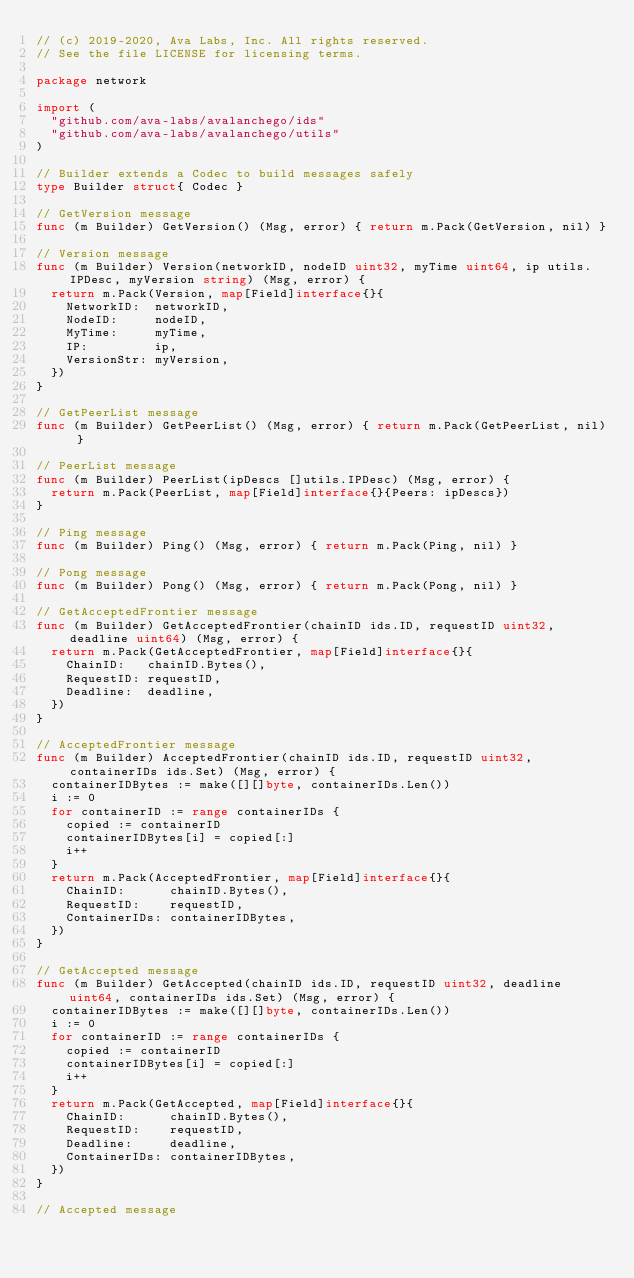Convert code to text. <code><loc_0><loc_0><loc_500><loc_500><_Go_>// (c) 2019-2020, Ava Labs, Inc. All rights reserved.
// See the file LICENSE for licensing terms.

package network

import (
	"github.com/ava-labs/avalanchego/ids"
	"github.com/ava-labs/avalanchego/utils"
)

// Builder extends a Codec to build messages safely
type Builder struct{ Codec }

// GetVersion message
func (m Builder) GetVersion() (Msg, error) { return m.Pack(GetVersion, nil) }

// Version message
func (m Builder) Version(networkID, nodeID uint32, myTime uint64, ip utils.IPDesc, myVersion string) (Msg, error) {
	return m.Pack(Version, map[Field]interface{}{
		NetworkID:  networkID,
		NodeID:     nodeID,
		MyTime:     myTime,
		IP:         ip,
		VersionStr: myVersion,
	})
}

// GetPeerList message
func (m Builder) GetPeerList() (Msg, error) { return m.Pack(GetPeerList, nil) }

// PeerList message
func (m Builder) PeerList(ipDescs []utils.IPDesc) (Msg, error) {
	return m.Pack(PeerList, map[Field]interface{}{Peers: ipDescs})
}

// Ping message
func (m Builder) Ping() (Msg, error) { return m.Pack(Ping, nil) }

// Pong message
func (m Builder) Pong() (Msg, error) { return m.Pack(Pong, nil) }

// GetAcceptedFrontier message
func (m Builder) GetAcceptedFrontier(chainID ids.ID, requestID uint32, deadline uint64) (Msg, error) {
	return m.Pack(GetAcceptedFrontier, map[Field]interface{}{
		ChainID:   chainID.Bytes(),
		RequestID: requestID,
		Deadline:  deadline,
	})
}

// AcceptedFrontier message
func (m Builder) AcceptedFrontier(chainID ids.ID, requestID uint32, containerIDs ids.Set) (Msg, error) {
	containerIDBytes := make([][]byte, containerIDs.Len())
	i := 0
	for containerID := range containerIDs {
		copied := containerID
		containerIDBytes[i] = copied[:]
		i++
	}
	return m.Pack(AcceptedFrontier, map[Field]interface{}{
		ChainID:      chainID.Bytes(),
		RequestID:    requestID,
		ContainerIDs: containerIDBytes,
	})
}

// GetAccepted message
func (m Builder) GetAccepted(chainID ids.ID, requestID uint32, deadline uint64, containerIDs ids.Set) (Msg, error) {
	containerIDBytes := make([][]byte, containerIDs.Len())
	i := 0
	for containerID := range containerIDs {
		copied := containerID
		containerIDBytes[i] = copied[:]
		i++
	}
	return m.Pack(GetAccepted, map[Field]interface{}{
		ChainID:      chainID.Bytes(),
		RequestID:    requestID,
		Deadline:     deadline,
		ContainerIDs: containerIDBytes,
	})
}

// Accepted message</code> 